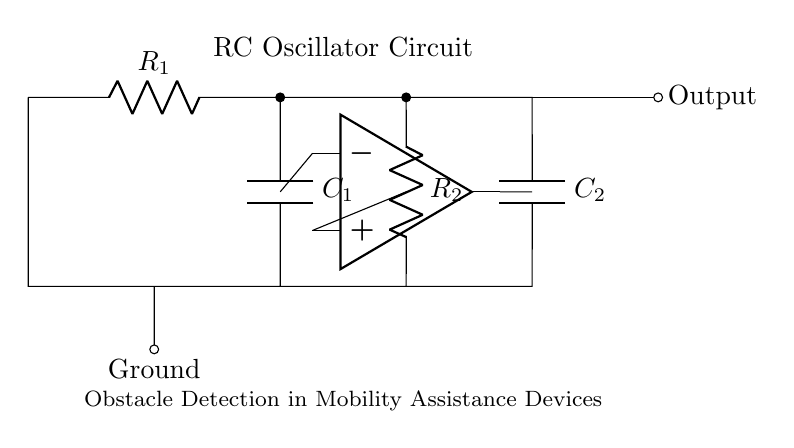What components are used in this RC oscillator circuit? The circuit includes two resistors (R1 and R2) and two capacitors (C1 and C2), forming an oscillator configuration.
Answer: Resistors and capacitors What is the output of this circuit? The output is taken from the point between the second resistor and the second capacitor, indicated in the diagram as "Output."
Answer: Output How many resistors are present in this circuit? The diagram clearly shows two resistors, R1 and R2, which are essential for the oscillator's function.
Answer: Two What is the main function of this RC oscillator circuit? The main function is obstacle detection in mobility assistance devices, as stated in the diagram.
Answer: Obstacle detection What type of circuit is depicted in this diagram? The circuit is an RC oscillator circuit, which is designed to generate oscillations based on resistor-capacitor timing elements.
Answer: RC oscillator circuit How does the capacitor influence the oscillation frequency? The frequency of oscillation is determined by the values of the resistors and capacitors; changing either will alter the time constant and therefore the frequency.
Answer: Depend on values of R and C 